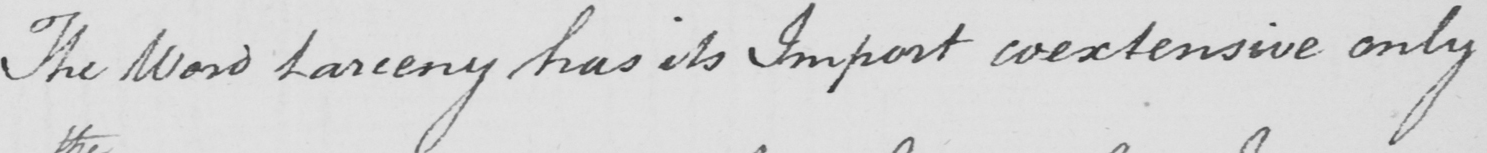Please provide the text content of this handwritten line. The Word Larceny has its Import coextensive only 